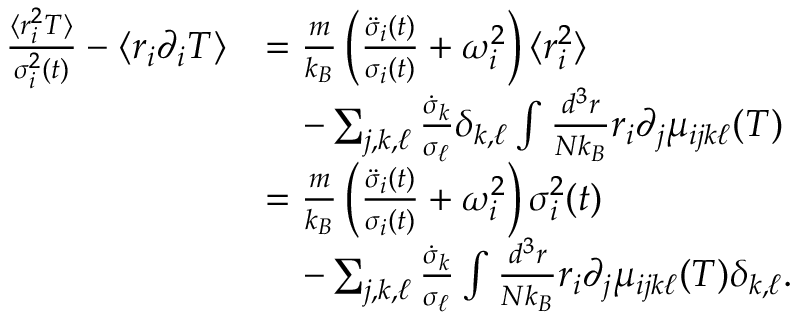Convert formula to latex. <formula><loc_0><loc_0><loc_500><loc_500>\begin{array} { r l } { \frac { \langle r _ { i } ^ { 2 } T \rangle } { \sigma _ { i } ^ { 2 } ( t ) } - \langle r _ { i } \partial _ { i } T \rangle } & { = \frac { m } { k _ { B } } \left ( \frac { \ddot { \sigma } _ { i } ( t ) } { \sigma _ { i } ( t ) } + \omega _ { i } ^ { 2 } \right ) \langle r _ { i } ^ { 2 } \rangle } \\ & { \quad - \sum _ { j , k , \ell } \frac { \dot { \sigma } _ { k } } { \sigma _ { \ell } } \delta _ { k , \ell } \int \frac { d ^ { 3 } r } { N k _ { B } } r _ { i } \partial _ { j } \mu _ { i j k \ell } ( T ) } \\ & { = \frac { m } { k _ { B } } \left ( \frac { \ddot { \sigma } _ { i } ( t ) } { \sigma _ { i } ( t ) } + \omega _ { i } ^ { 2 } \right ) \sigma _ { i } ^ { 2 } ( t ) } \\ & { \quad - \sum _ { j , k , \ell } \frac { \dot { \sigma } _ { k } } { \sigma _ { \ell } } \int \frac { d ^ { 3 } r } { N k _ { B } } r _ { i } \partial _ { j } \mu _ { i j k \ell } ( T ) \delta _ { k , \ell } . } \end{array}</formula> 